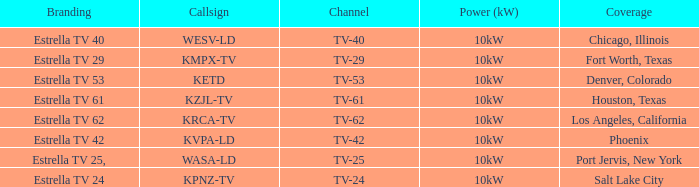In which city did kpnz-tv deliver coverage? Salt Lake City. 